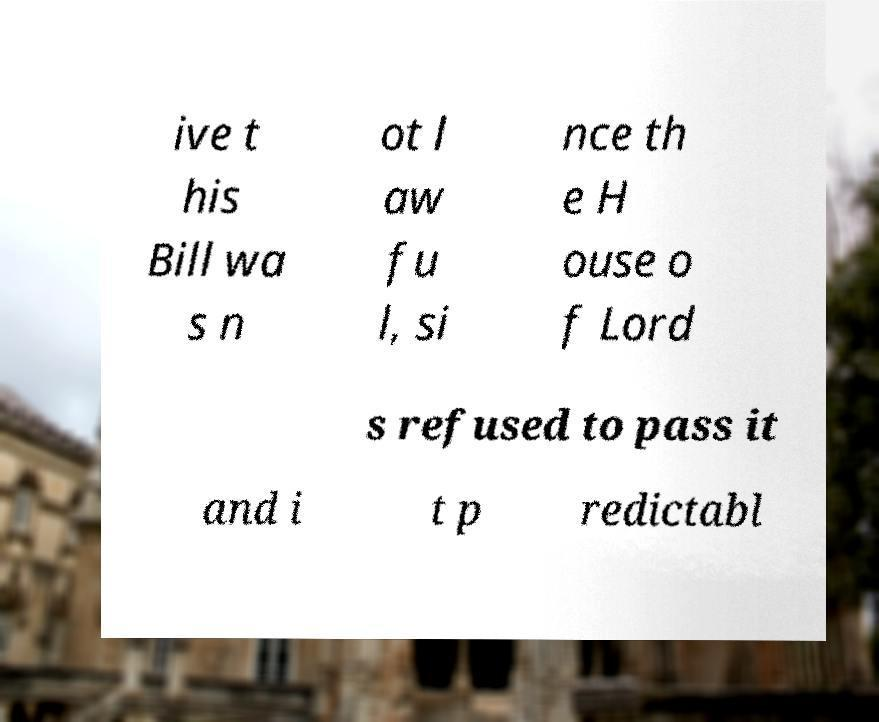What messages or text are displayed in this image? I need them in a readable, typed format. ive t his Bill wa s n ot l aw fu l, si nce th e H ouse o f Lord s refused to pass it and i t p redictabl 